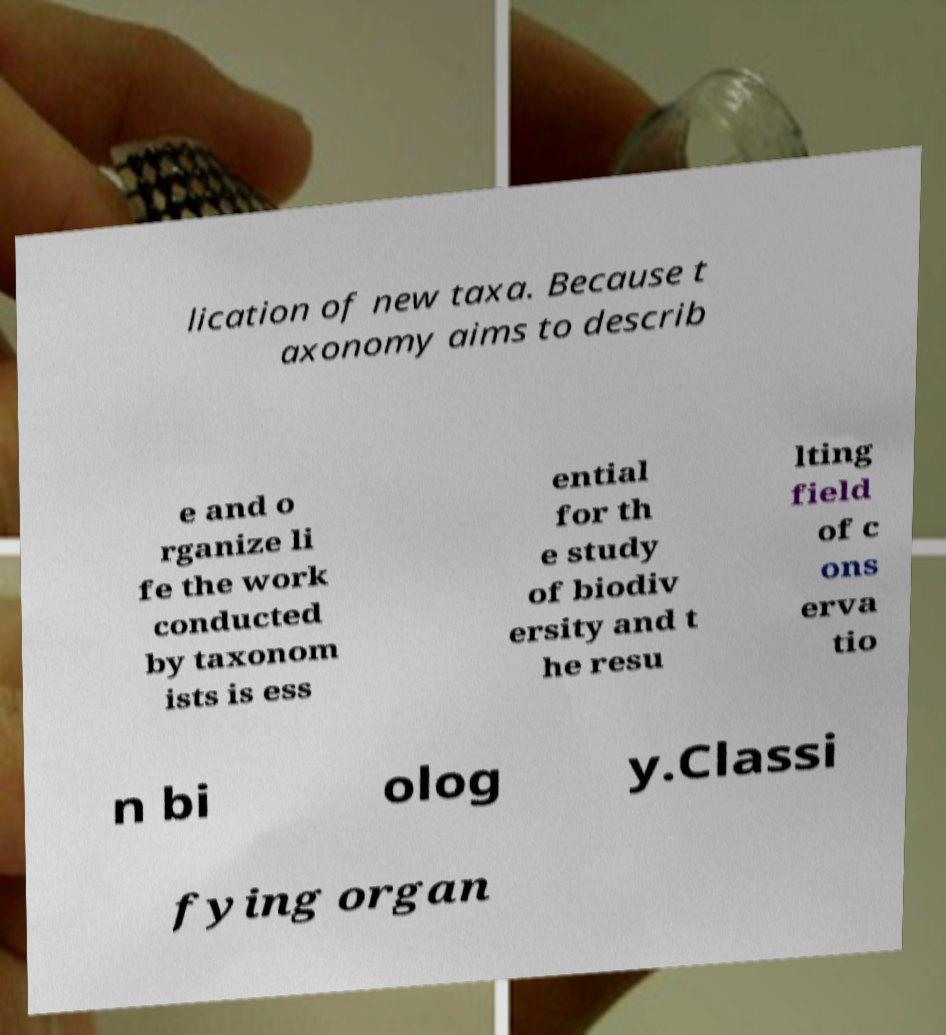Can you read and provide the text displayed in the image?This photo seems to have some interesting text. Can you extract and type it out for me? lication of new taxa. Because t axonomy aims to describ e and o rganize li fe the work conducted by taxonom ists is ess ential for th e study of biodiv ersity and t he resu lting field of c ons erva tio n bi olog y.Classi fying organ 